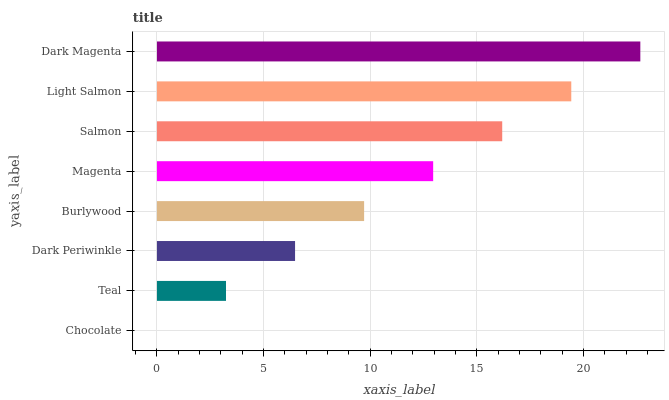Is Chocolate the minimum?
Answer yes or no. Yes. Is Dark Magenta the maximum?
Answer yes or no. Yes. Is Teal the minimum?
Answer yes or no. No. Is Teal the maximum?
Answer yes or no. No. Is Teal greater than Chocolate?
Answer yes or no. Yes. Is Chocolate less than Teal?
Answer yes or no. Yes. Is Chocolate greater than Teal?
Answer yes or no. No. Is Teal less than Chocolate?
Answer yes or no. No. Is Magenta the high median?
Answer yes or no. Yes. Is Burlywood the low median?
Answer yes or no. Yes. Is Teal the high median?
Answer yes or no. No. Is Dark Periwinkle the low median?
Answer yes or no. No. 